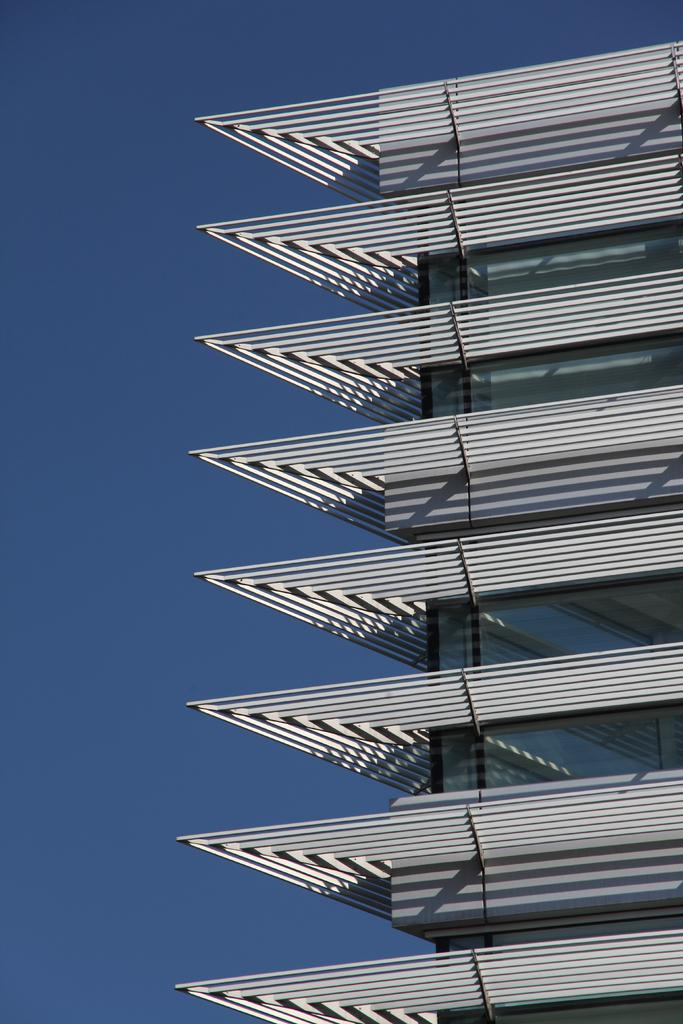What type of structure is depicted in the image? There is an architectural building in the image. What can be seen in the background of the image? The sky is visible in the background of the image. Is there a watch visible on the building in the image? There is no watch present on the building in the image. Can you tell me how many parcels are being delivered to the building in the image? There is no information about parcels or deliveries in the image. 